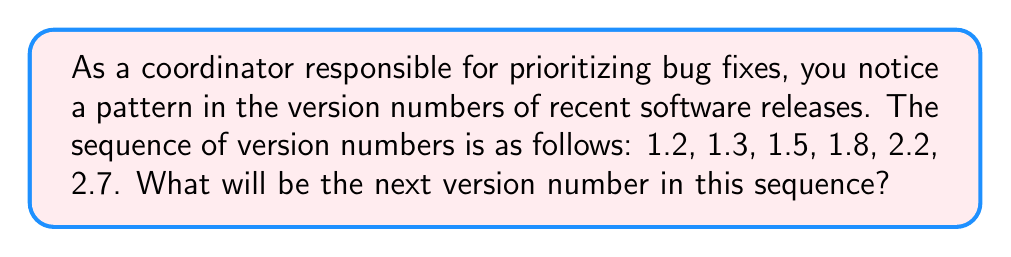What is the answer to this math problem? To find the pattern in this sequence of software version numbers, let's analyze the differences between consecutive terms:

1. From 1.2 to 1.3: $1.3 - 1.2 = 0.1$
2. From 1.3 to 1.5: $1.5 - 1.3 = 0.2$
3. From 1.5 to 1.8: $1.8 - 1.5 = 0.3$
4. From 1.8 to 2.2: $2.2 - 1.8 = 0.4$
5. From 2.2 to 2.7: $2.7 - 2.2 = 0.5$

We can observe that the difference between consecutive terms is increasing by 0.1 each time:

$$0.1 \rightarrow 0.2 \rightarrow 0.3 \rightarrow 0.4 \rightarrow 0.5$$

Following this pattern, the next difference should be 0.6.

To find the next version number, we add 0.6 to the last term in the sequence:

$$2.7 + 0.6 = 3.3$$

Therefore, the next version number in the sequence will be 3.3.
Answer: 3.3 